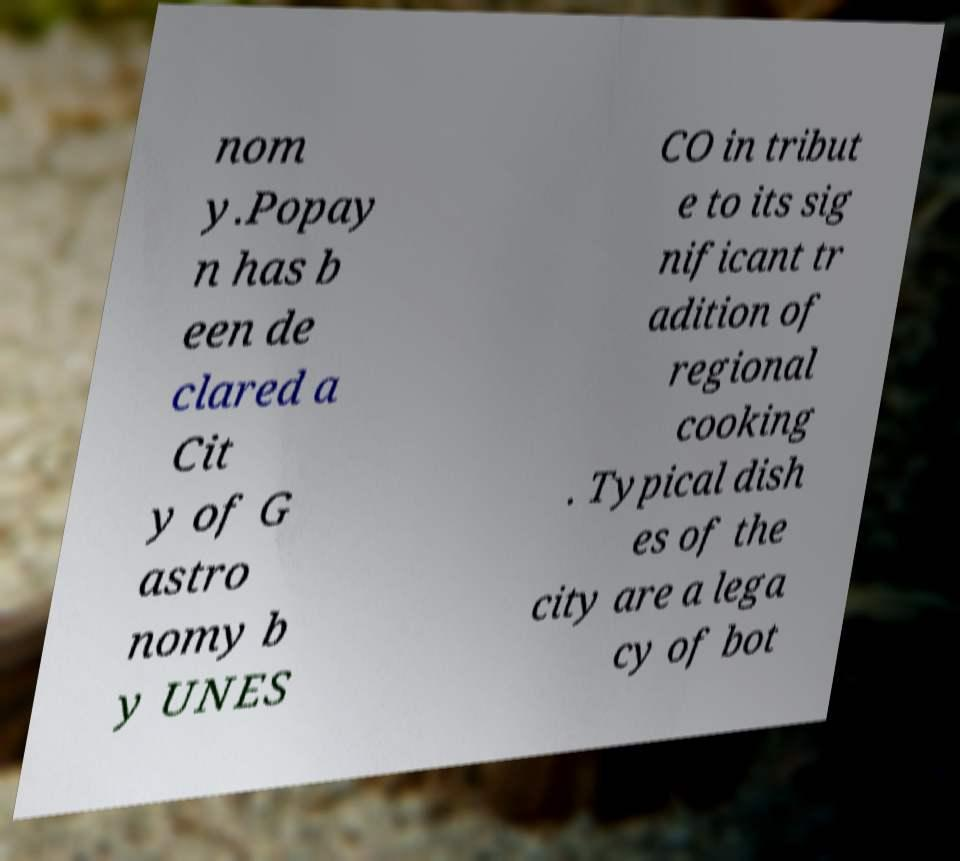Can you read and provide the text displayed in the image?This photo seems to have some interesting text. Can you extract and type it out for me? nom y.Popay n has b een de clared a Cit y of G astro nomy b y UNES CO in tribut e to its sig nificant tr adition of regional cooking . Typical dish es of the city are a lega cy of bot 